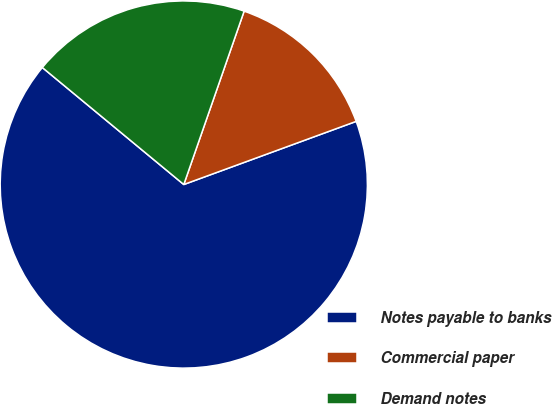Convert chart to OTSL. <chart><loc_0><loc_0><loc_500><loc_500><pie_chart><fcel>Notes payable to banks<fcel>Commercial paper<fcel>Demand notes<nl><fcel>66.58%<fcel>14.08%<fcel>19.33%<nl></chart> 